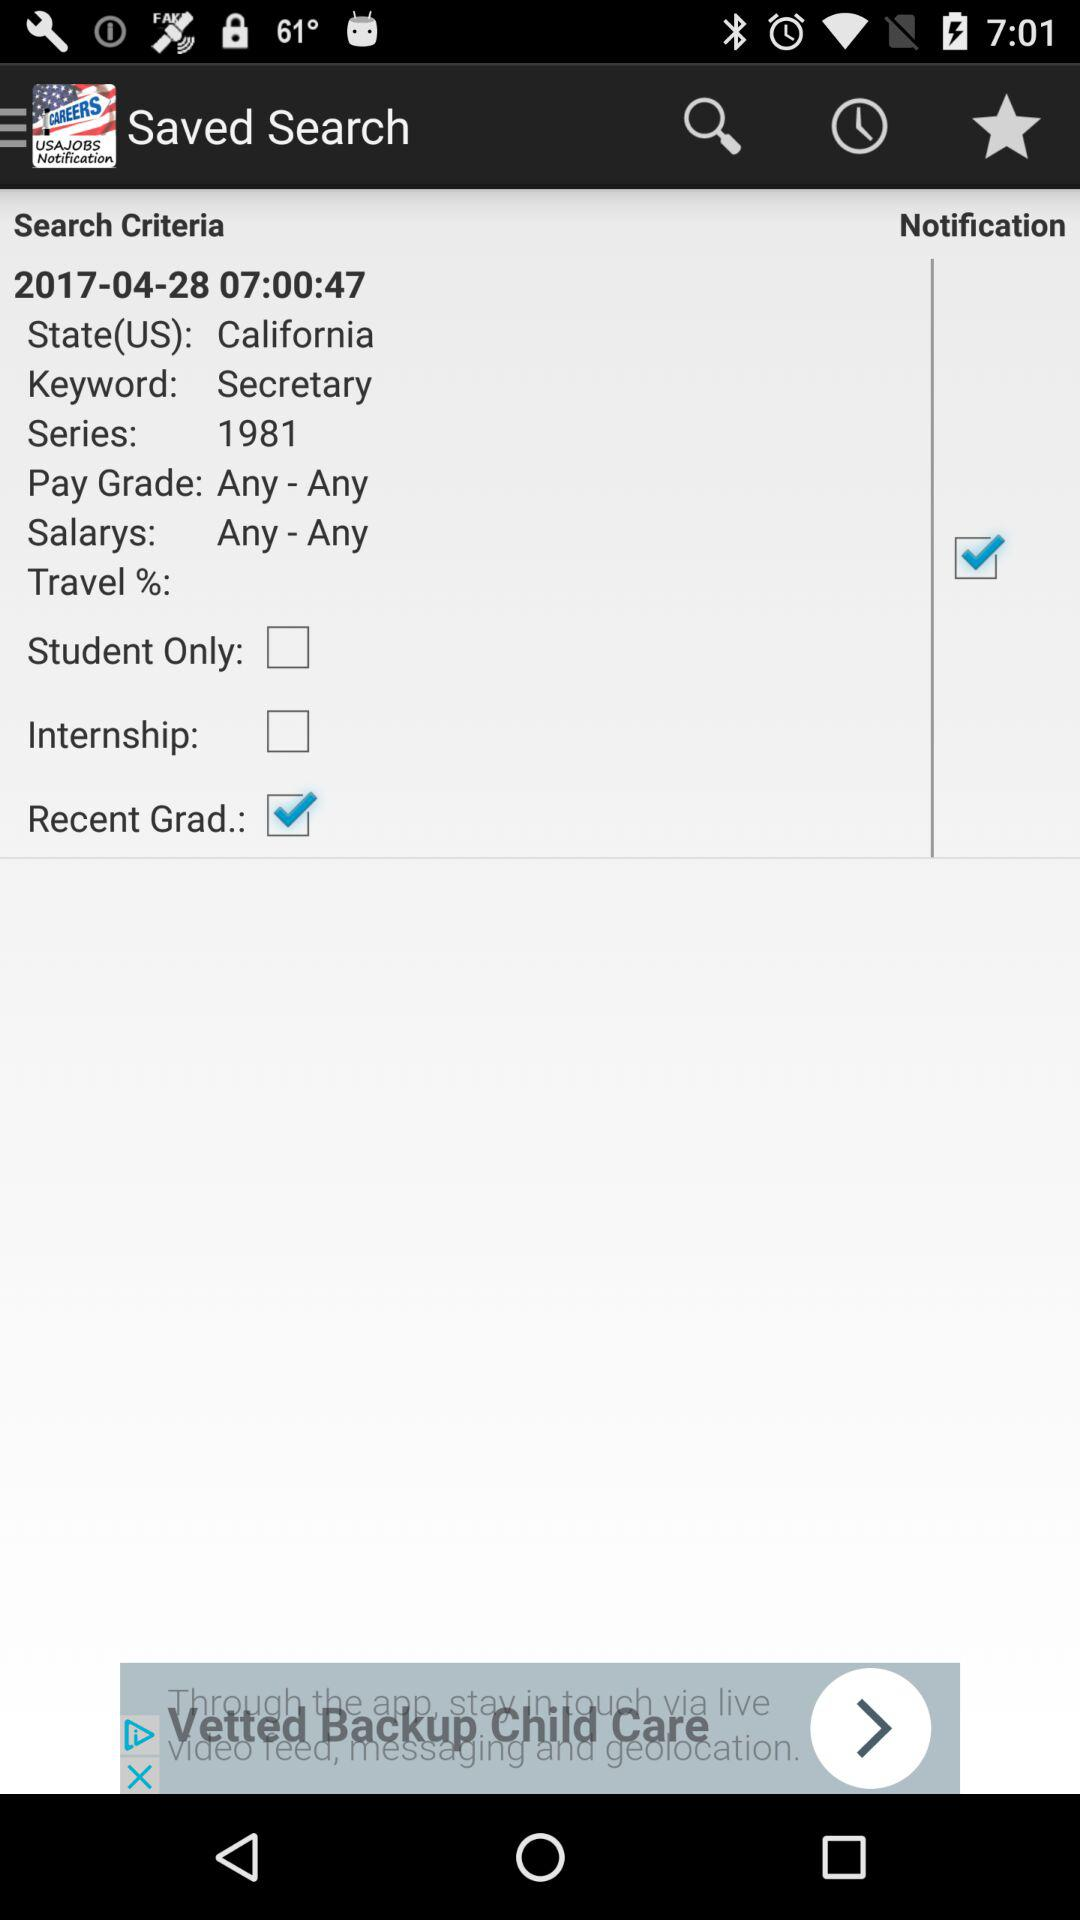What is the country's name? The country's name is "US". 